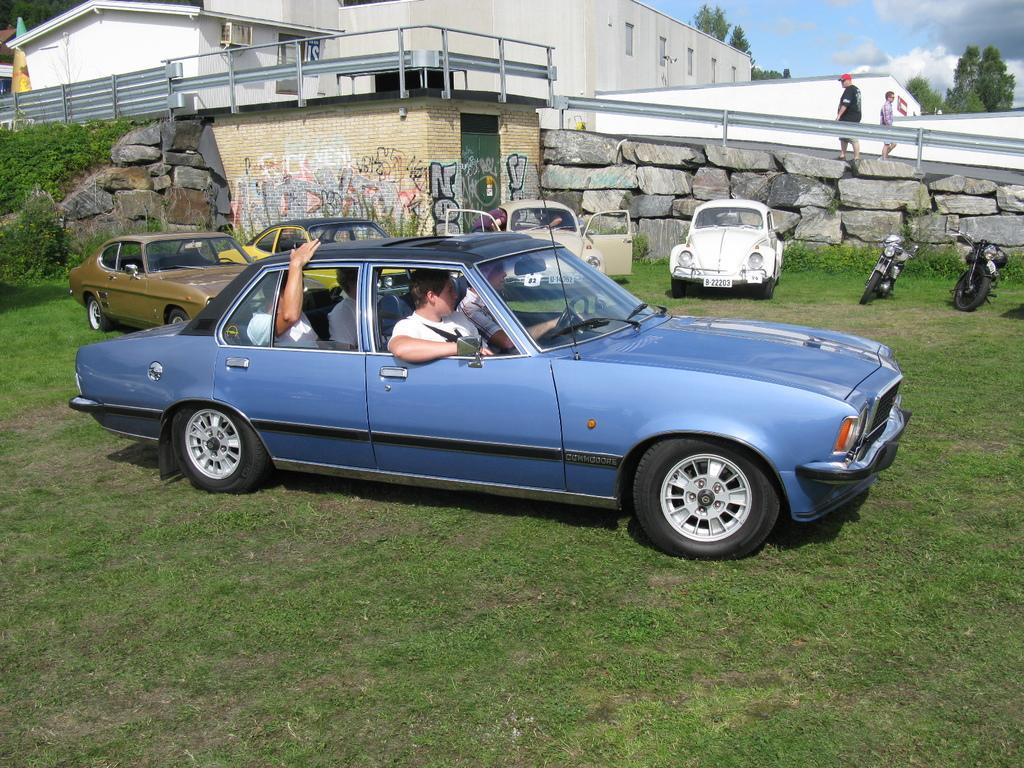Could you give a brief overview of what you see in this image? This picture is taken in a garden, In the middle there is a car which is in blue color, There are some people sitting in a car, In the background there are some cars and in the right side there some bikes, In the background there is a wall which is made of stones in white color, There are some people walking on the wall. 